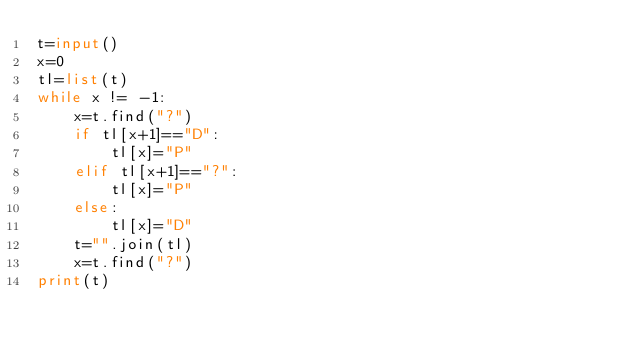Convert code to text. <code><loc_0><loc_0><loc_500><loc_500><_Python_>t=input()
x=0
tl=list(t)
while x != -1:
    x=t.find("?")
    if tl[x+1]=="D":
        tl[x]="P"
    elif tl[x+1]=="?":
        tl[x]="P"
    else:
        tl[x]="D"
    t="".join(tl)
    x=t.find("?")
print(t)</code> 